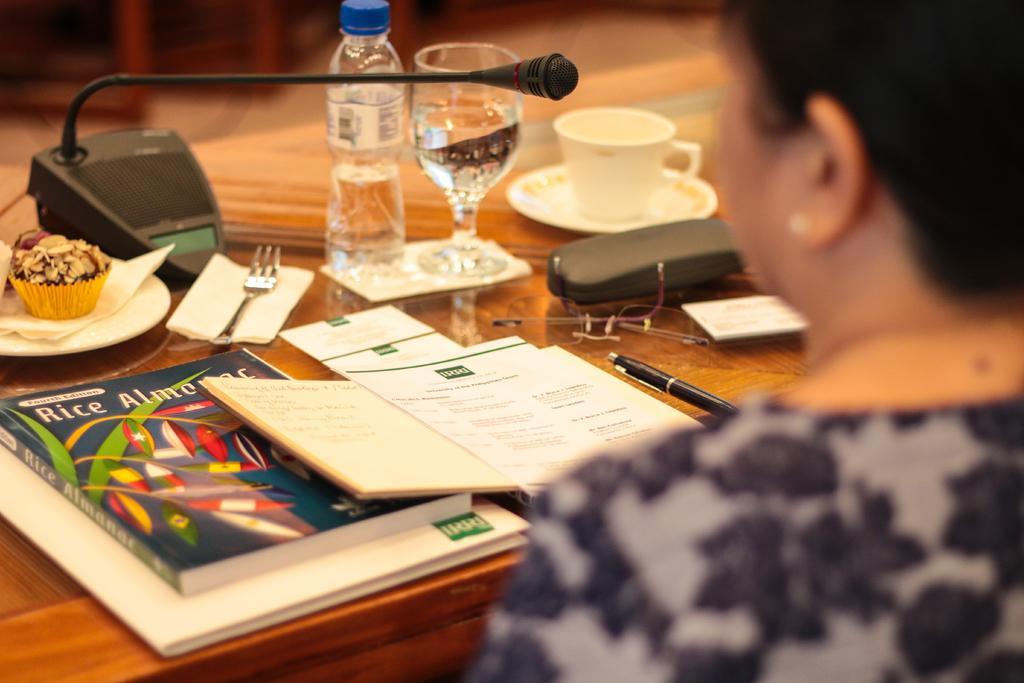Describe this image in one or two sentences. In the image we can see one person sitting on chair around table. On table we can see books,pen,bottle,glass,cup,microphone etc. 